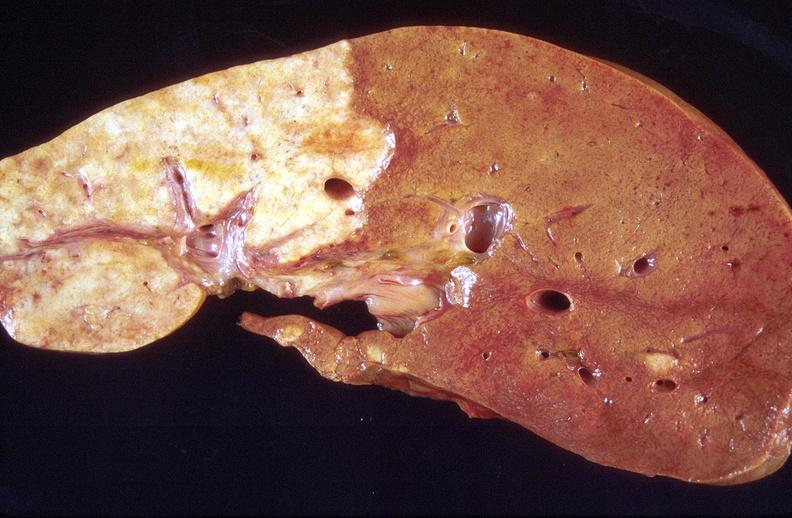s liver present?
Answer the question using a single word or phrase. Yes 